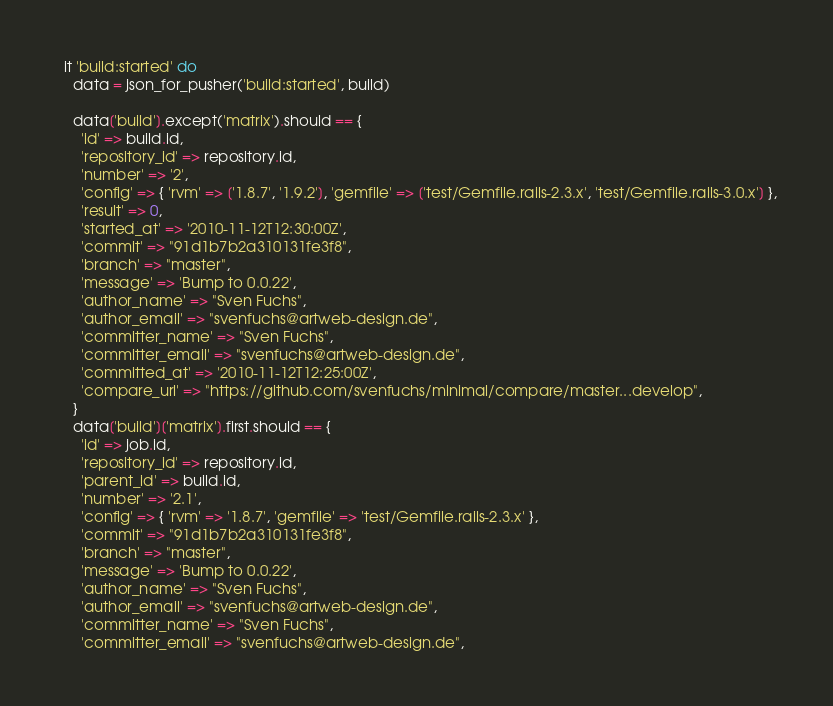<code> <loc_0><loc_0><loc_500><loc_500><_Ruby_>  it 'build:started' do
    data = json_for_pusher('build:started', build)

    data['build'].except('matrix').should == {
      'id' => build.id,
      'repository_id' => repository.id,
      'number' => '2',
      'config' => { 'rvm' => ['1.8.7', '1.9.2'], 'gemfile' => ['test/Gemfile.rails-2.3.x', 'test/Gemfile.rails-3.0.x'] },
      'result' => 0,
      'started_at' => '2010-11-12T12:30:00Z',
      'commit' => "91d1b7b2a310131fe3f8",
      'branch' => "master",
      'message' => 'Bump to 0.0.22',
      'author_name' => "Sven Fuchs",
      'author_email' => "svenfuchs@artweb-design.de",
      'committer_name' => "Sven Fuchs",
      'committer_email' => "svenfuchs@artweb-design.de",
      'committed_at' => '2010-11-12T12:25:00Z',
      'compare_url' => "https://github.com/svenfuchs/minimal/compare/master...develop",
    }
    data['build']['matrix'].first.should == {
      'id' => job.id,
      'repository_id' => repository.id,
      'parent_id' => build.id,
      'number' => '2.1',
      'config' => { 'rvm' => '1.8.7', 'gemfile' => 'test/Gemfile.rails-2.3.x' },
      'commit' => "91d1b7b2a310131fe3f8",
      'branch' => "master",
      'message' => 'Bump to 0.0.22',
      'author_name' => "Sven Fuchs",
      'author_email' => "svenfuchs@artweb-design.de",
      'committer_name' => "Sven Fuchs",
      'committer_email' => "svenfuchs@artweb-design.de",</code> 